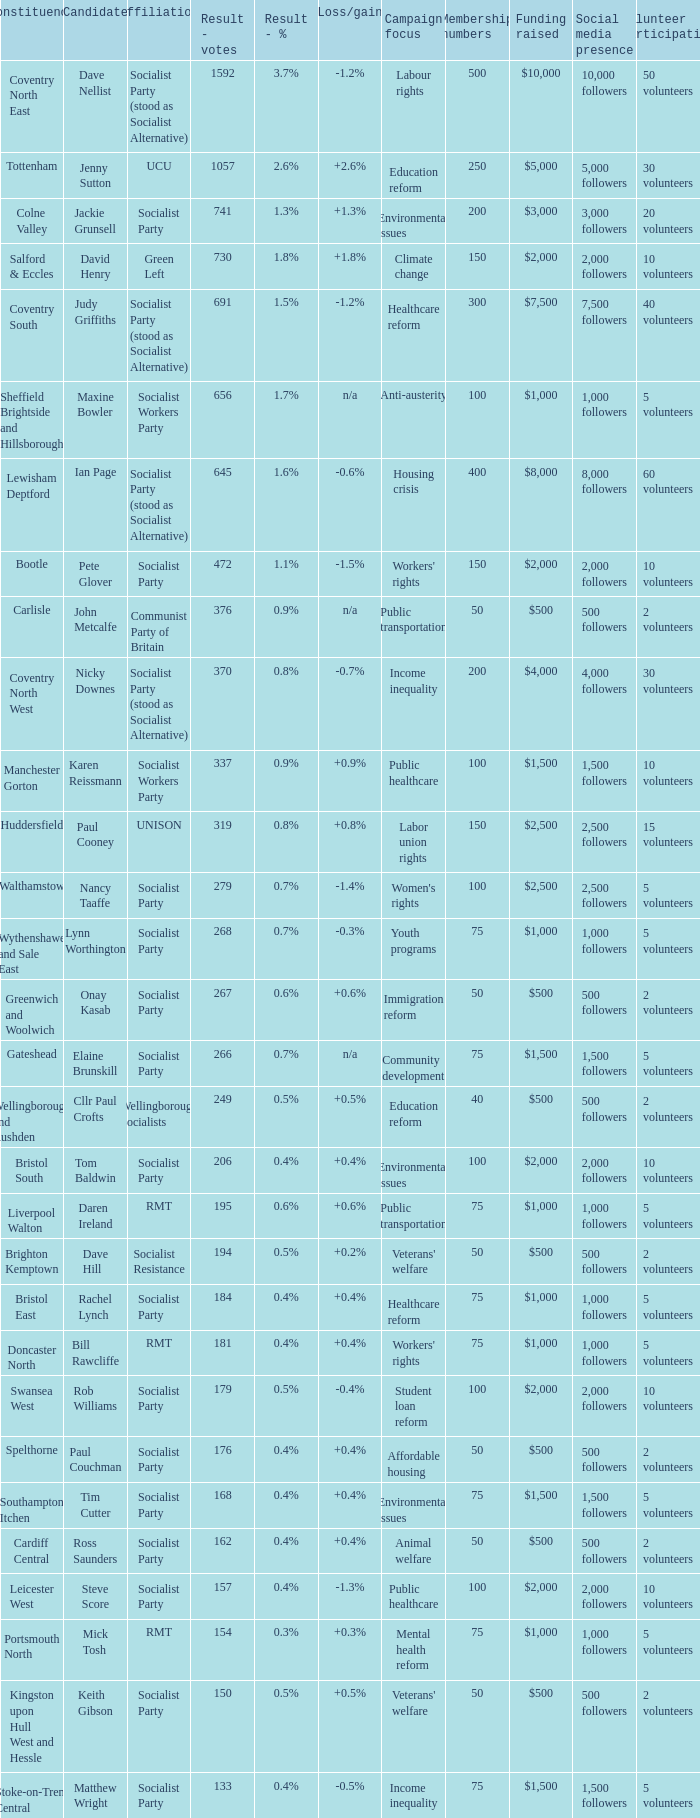What is the largest vote result if loss/gain is -0.5%? 133.0. 